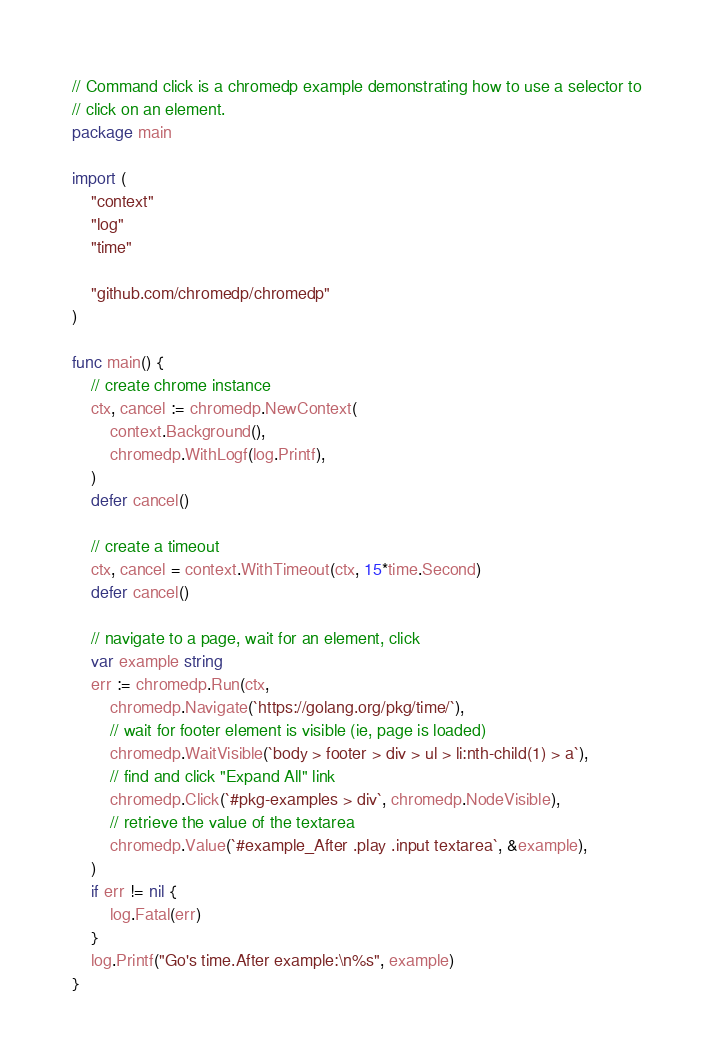<code> <loc_0><loc_0><loc_500><loc_500><_Go_>// Command click is a chromedp example demonstrating how to use a selector to
// click on an element.
package main

import (
	"context"
	"log"
	"time"

	"github.com/chromedp/chromedp"
)

func main() {
	// create chrome instance
	ctx, cancel := chromedp.NewContext(
		context.Background(),
		chromedp.WithLogf(log.Printf),
	)
	defer cancel()

	// create a timeout
	ctx, cancel = context.WithTimeout(ctx, 15*time.Second)
	defer cancel()

	// navigate to a page, wait for an element, click
	var example string
	err := chromedp.Run(ctx,
		chromedp.Navigate(`https://golang.org/pkg/time/`),
		// wait for footer element is visible (ie, page is loaded)
		chromedp.WaitVisible(`body > footer > div > ul > li:nth-child(1) > a`),
		// find and click "Expand All" link
		chromedp.Click(`#pkg-examples > div`, chromedp.NodeVisible),
		// retrieve the value of the textarea
		chromedp.Value(`#example_After .play .input textarea`, &example),
	)
	if err != nil {
		log.Fatal(err)
	}
	log.Printf("Go's time.After example:\n%s", example)
}
</code> 